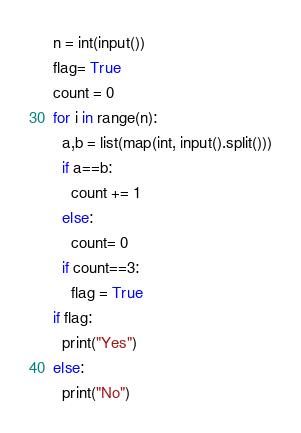<code> <loc_0><loc_0><loc_500><loc_500><_Python_>n = int(input())
flag= True
count = 0
for i in range(n):
  a,b = list(map(int, input().split()))
  if a==b:
    count += 1
  else:
    count= 0
  if count==3:
    flag = True
if flag:
  print("Yes")
else:
  print("No")</code> 